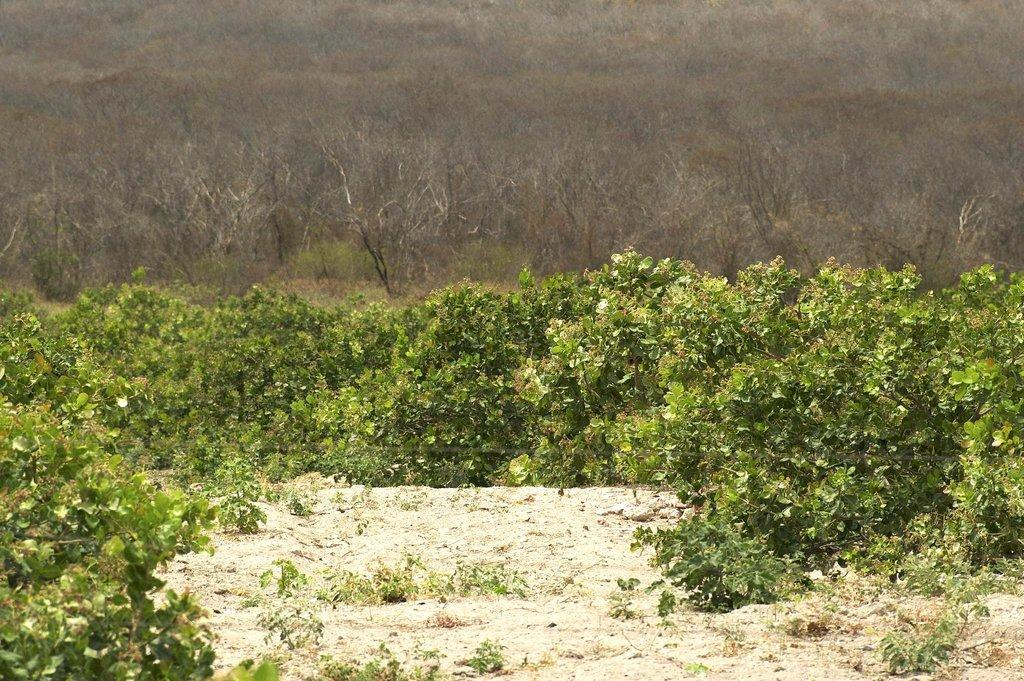What type of vegetation is present in the image? There are trees in the image. Where are the trees located? The trees are on the ground. What type of net is being used to catch the trees in the image? There is no net present in the image, and the trees are not being caught. 